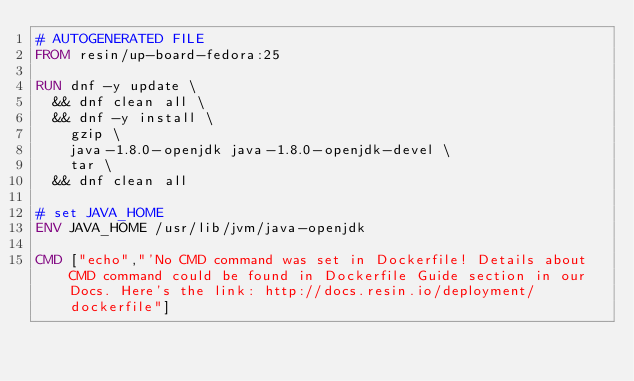<code> <loc_0><loc_0><loc_500><loc_500><_Dockerfile_># AUTOGENERATED FILE
FROM resin/up-board-fedora:25

RUN dnf -y update \
	&& dnf clean all \
	&& dnf -y install \
		gzip \
		java-1.8.0-openjdk java-1.8.0-openjdk-devel \
		tar \
	&& dnf clean all

# set JAVA_HOME
ENV JAVA_HOME /usr/lib/jvm/java-openjdk

CMD ["echo","'No CMD command was set in Dockerfile! Details about CMD command could be found in Dockerfile Guide section in our Docs. Here's the link: http://docs.resin.io/deployment/dockerfile"]</code> 